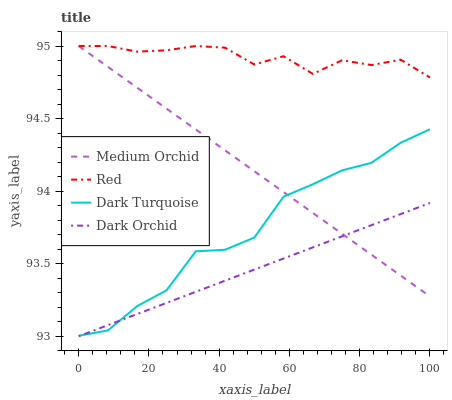Does Dark Orchid have the minimum area under the curve?
Answer yes or no. Yes. Does Red have the maximum area under the curve?
Answer yes or no. Yes. Does Medium Orchid have the minimum area under the curve?
Answer yes or no. No. Does Medium Orchid have the maximum area under the curve?
Answer yes or no. No. Is Dark Orchid the smoothest?
Answer yes or no. Yes. Is Dark Turquoise the roughest?
Answer yes or no. Yes. Is Medium Orchid the smoothest?
Answer yes or no. No. Is Medium Orchid the roughest?
Answer yes or no. No. Does Dark Orchid have the lowest value?
Answer yes or no. Yes. Does Medium Orchid have the lowest value?
Answer yes or no. No. Does Red have the highest value?
Answer yes or no. Yes. Does Dark Orchid have the highest value?
Answer yes or no. No. Is Dark Turquoise less than Red?
Answer yes or no. Yes. Is Red greater than Dark Turquoise?
Answer yes or no. Yes. Does Dark Turquoise intersect Dark Orchid?
Answer yes or no. Yes. Is Dark Turquoise less than Dark Orchid?
Answer yes or no. No. Is Dark Turquoise greater than Dark Orchid?
Answer yes or no. No. Does Dark Turquoise intersect Red?
Answer yes or no. No. 